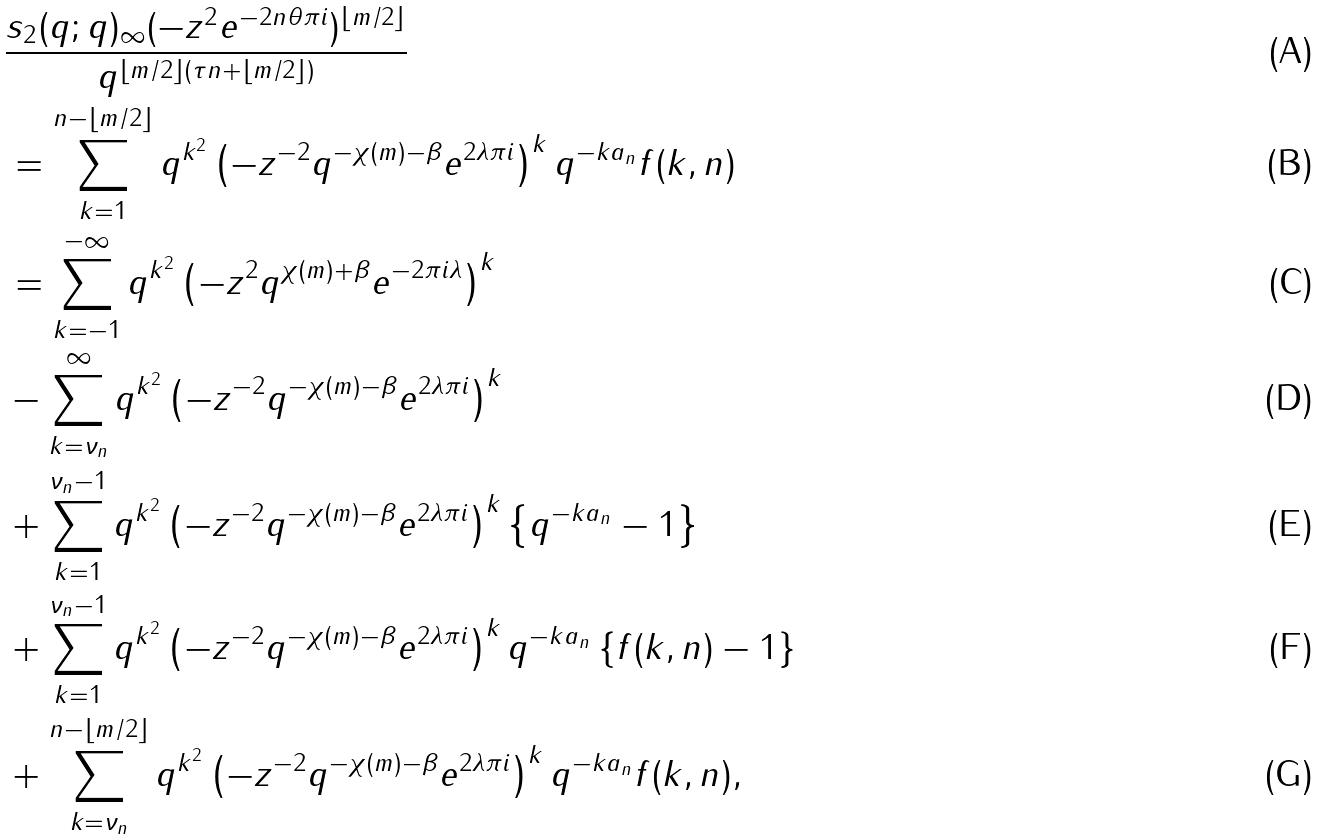<formula> <loc_0><loc_0><loc_500><loc_500>& \frac { s _ { 2 } ( q ; q ) _ { \infty } ( - z ^ { 2 } e ^ { - 2 n \theta \pi i } ) ^ { \left \lfloor m / 2 \right \rfloor } } { q ^ { \left \lfloor m / 2 \right \rfloor ( \tau n + \left \lfloor m / 2 \right \rfloor ) } } \\ & = \sum _ { k = 1 } ^ { n - \left \lfloor m / 2 \right \rfloor } q ^ { k ^ { 2 } } \left ( - z ^ { - 2 } q ^ { - \chi ( m ) - \beta } e ^ { 2 \lambda \pi i } \right ) ^ { k } q ^ { - k a _ { n } } f ( k , n ) \\ & = \sum _ { k = - 1 } ^ { - \infty } q ^ { k ^ { 2 } } \left ( - z ^ { 2 } q ^ { \chi ( m ) + \beta } e ^ { - 2 \pi i \lambda } \right ) ^ { k } \\ & - \sum _ { k = \nu _ { n } } ^ { \infty } q ^ { k ^ { 2 } } \left ( - z ^ { - 2 } q ^ { - \chi ( m ) - \beta } e ^ { 2 \lambda \pi i } \right ) ^ { k } \\ & + \sum _ { k = 1 } ^ { \nu _ { n } - 1 } q ^ { k ^ { 2 } } \left ( - z ^ { - 2 } q ^ { - \chi ( m ) - \beta } e ^ { 2 \lambda \pi i } \right ) ^ { k } \left \{ q ^ { - k a _ { n } } - 1 \right \} \\ & + \sum _ { k = 1 } ^ { \nu _ { n } - 1 } q ^ { k ^ { 2 } } \left ( - z ^ { - 2 } q ^ { - \chi ( m ) - \beta } e ^ { 2 \lambda \pi i } \right ) ^ { k } q ^ { - k a _ { n } } \left \{ f ( k , n ) - 1 \right \} \\ & + \sum _ { k = \nu _ { n } } ^ { n - \left \lfloor m / 2 \right \rfloor } q ^ { k ^ { 2 } } \left ( - z ^ { - 2 } q ^ { - \chi ( m ) - \beta } e ^ { 2 \lambda \pi i } \right ) ^ { k } q ^ { - k a _ { n } } f ( k , n ) ,</formula> 